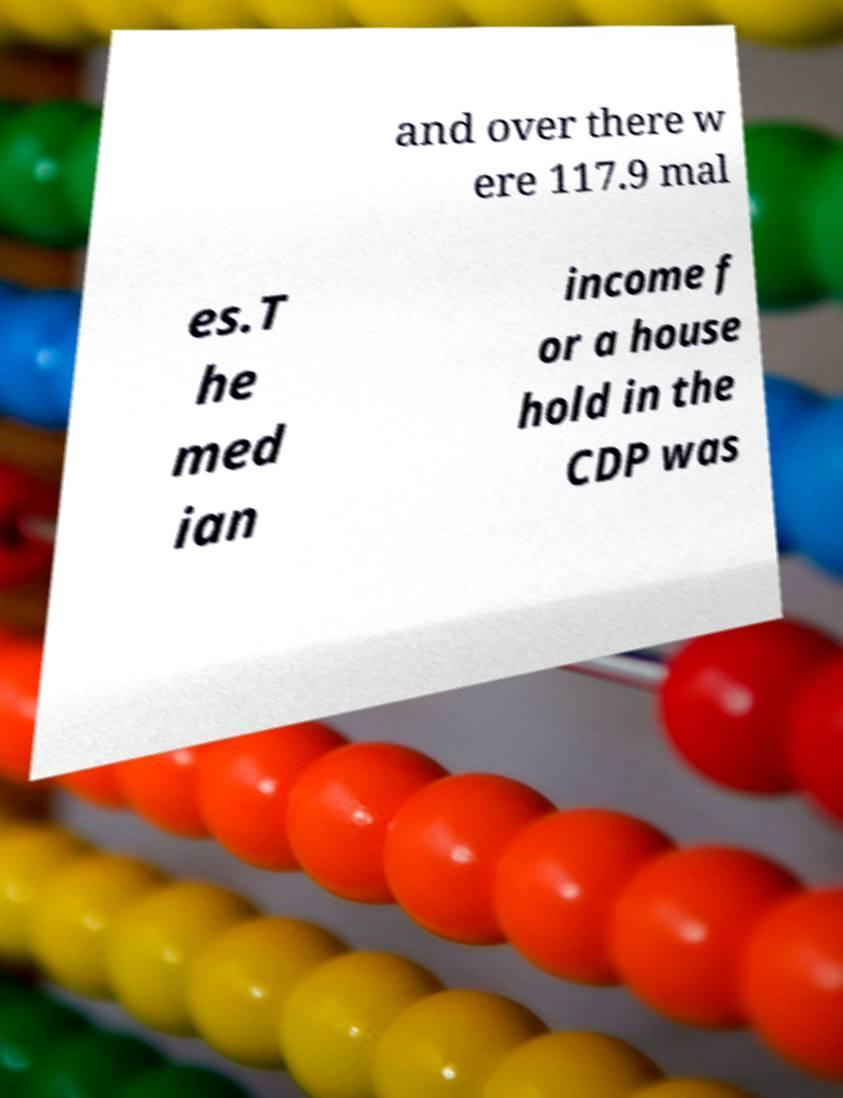Please read and relay the text visible in this image. What does it say? and over there w ere 117.9 mal es.T he med ian income f or a house hold in the CDP was 